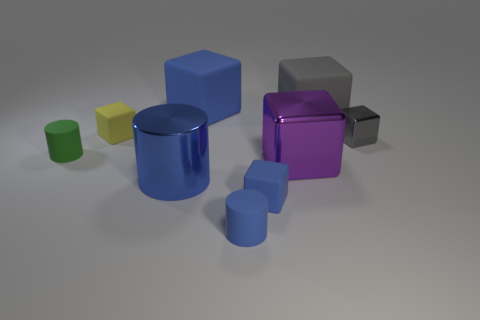Subtract all gray spheres. How many blue cylinders are left? 2 Subtract all tiny yellow matte cubes. How many cubes are left? 5 Subtract all yellow blocks. How many blocks are left? 5 Add 1 big objects. How many objects exist? 10 Subtract all yellow cubes. Subtract all green cylinders. How many cubes are left? 5 Subtract all cubes. How many objects are left? 3 Subtract 0 purple spheres. How many objects are left? 9 Subtract all large shiny things. Subtract all tiny brown cylinders. How many objects are left? 7 Add 5 blue cubes. How many blue cubes are left? 7 Add 5 large yellow matte objects. How many large yellow matte objects exist? 5 